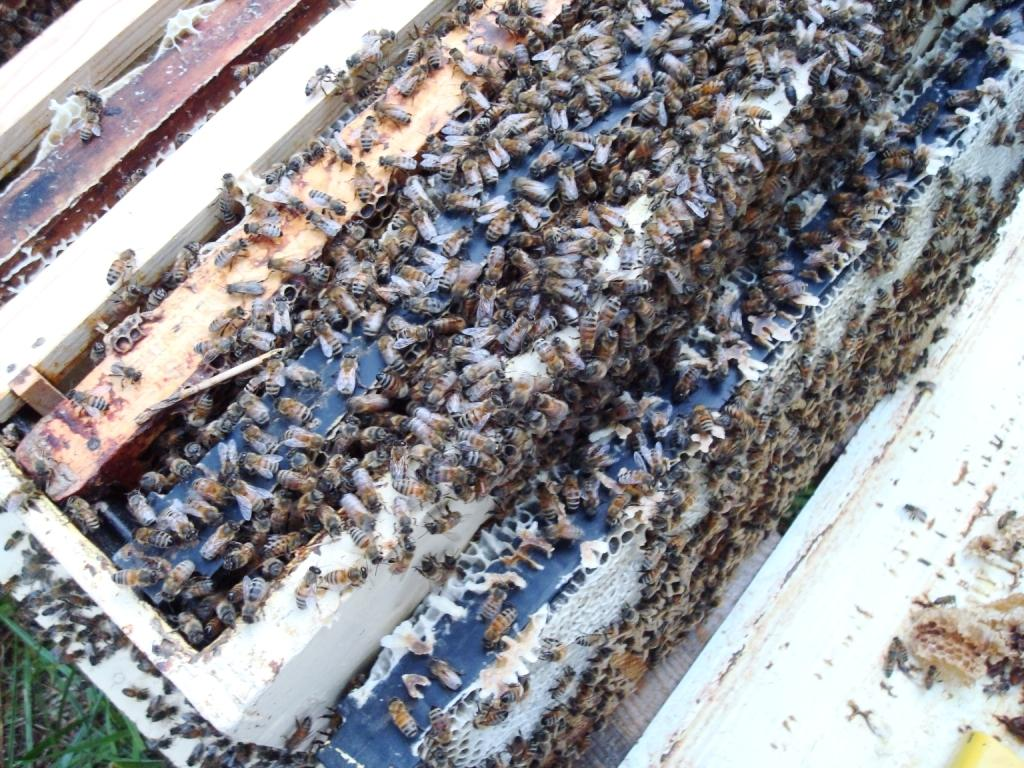What is the main subject of the image? The main subject of the image is a honey bee hive box. Can you describe what else is present in the image? Yes, there are many honey bees in the image. What type of army is depicted in the image? There is no army present in the image; it features a honey bee hive box and honey bees. What shape is the lumber in the image? There is no lumber present in the image. 